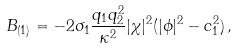Convert formula to latex. <formula><loc_0><loc_0><loc_500><loc_500>B _ { ( 1 ) } = - 2 \sigma _ { 1 } \frac { q _ { 1 } q _ { 2 } ^ { 2 } } { \kappa ^ { 2 } } | \chi | ^ { 2 } ( | \phi | ^ { 2 } - c _ { 1 } ^ { 2 } ) \, ,</formula> 